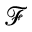Convert formula to latex. <formula><loc_0><loc_0><loc_500><loc_500>\mathcal { F }</formula> 